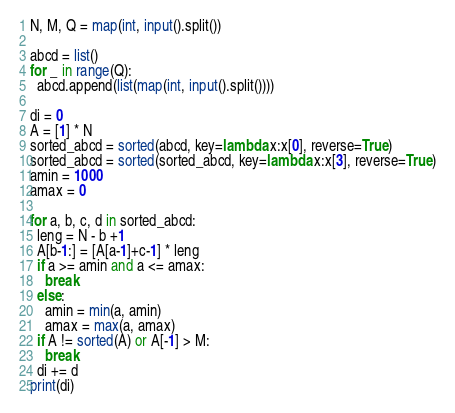Convert code to text. <code><loc_0><loc_0><loc_500><loc_500><_Python_>N, M, Q = map(int, input().split())

abcd = list()
for _ in range(Q):
  abcd.append(list(map(int, input().split())))

di = 0
A = [1] * N
sorted_abcd = sorted(abcd, key=lambda x:x[0], reverse=True)
sorted_abcd = sorted(sorted_abcd, key=lambda x:x[3], reverse=True)
amin = 1000
amax = 0

for a, b, c, d in sorted_abcd:
  leng = N - b +1
  A[b-1:] = [A[a-1]+c-1] * leng
  if a >= amin and a <= amax:
    break
  else:
    amin = min(a, amin)
    amax = max(a, amax)
  if A != sorted(A) or A[-1] > M:
    break
  di += d
print(di)</code> 